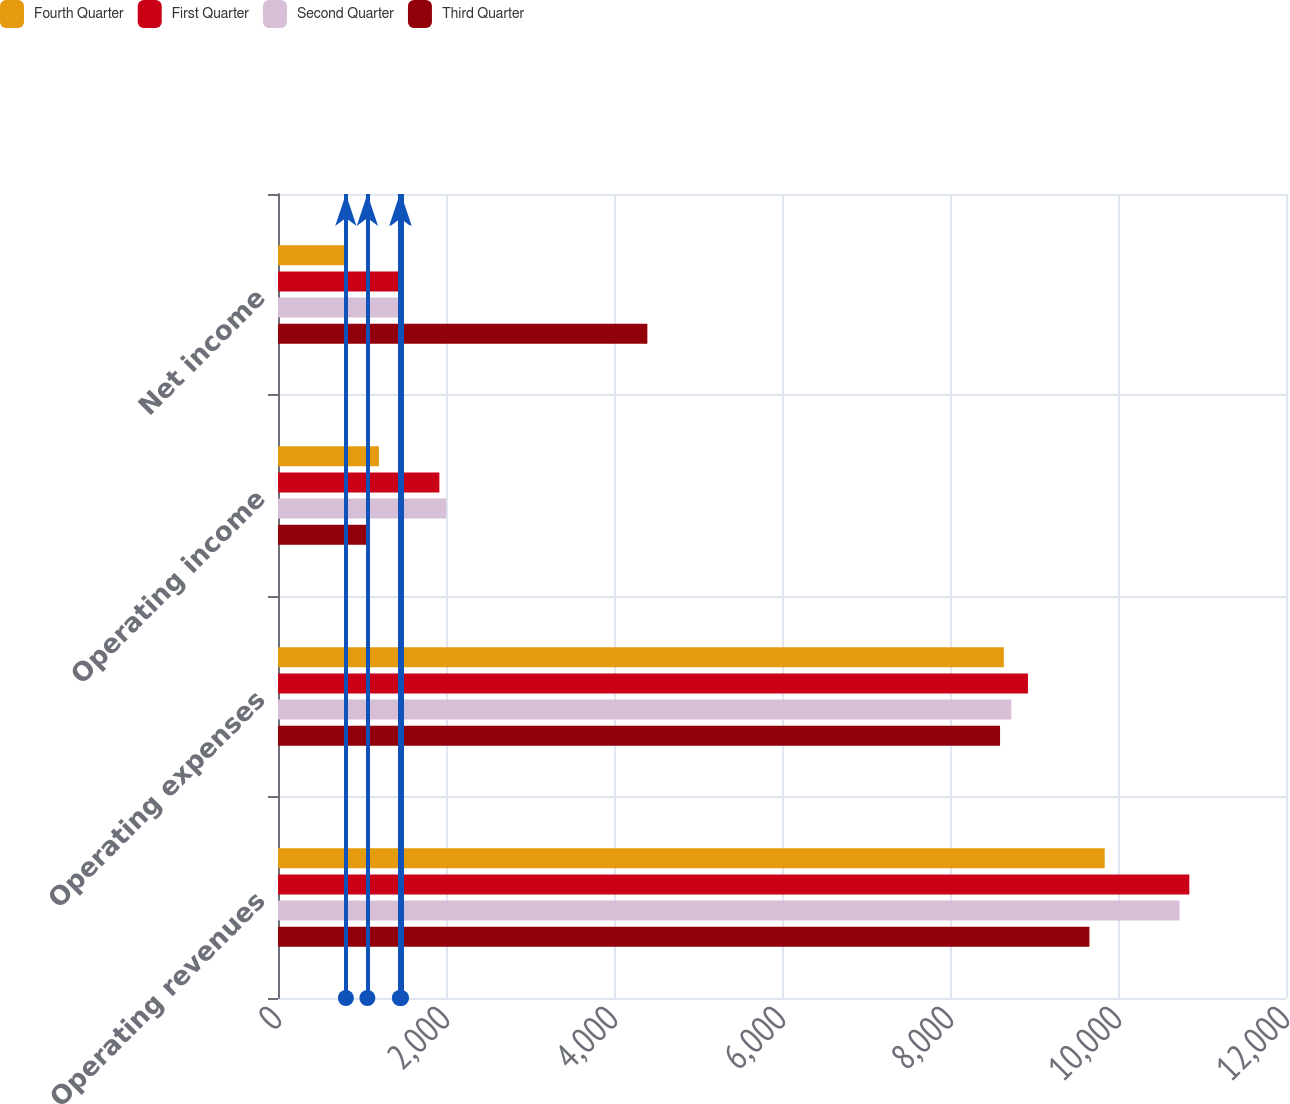Convert chart to OTSL. <chart><loc_0><loc_0><loc_500><loc_500><stacked_bar_chart><ecel><fcel>Operating revenues<fcel>Operating expenses<fcel>Operating income<fcel>Net income<nl><fcel>Fourth Quarter<fcel>9842<fcel>8641<fcel>1201<fcel>808<nl><fcel>First Quarter<fcel>10849<fcel>8928<fcel>1921<fcel>1465<nl><fcel>Second Quarter<fcel>10733<fcel>8730<fcel>2003<fcel>1450<nl><fcel>Third Quarter<fcel>9660<fcel>8596<fcel>1064<fcel>4397<nl></chart> 